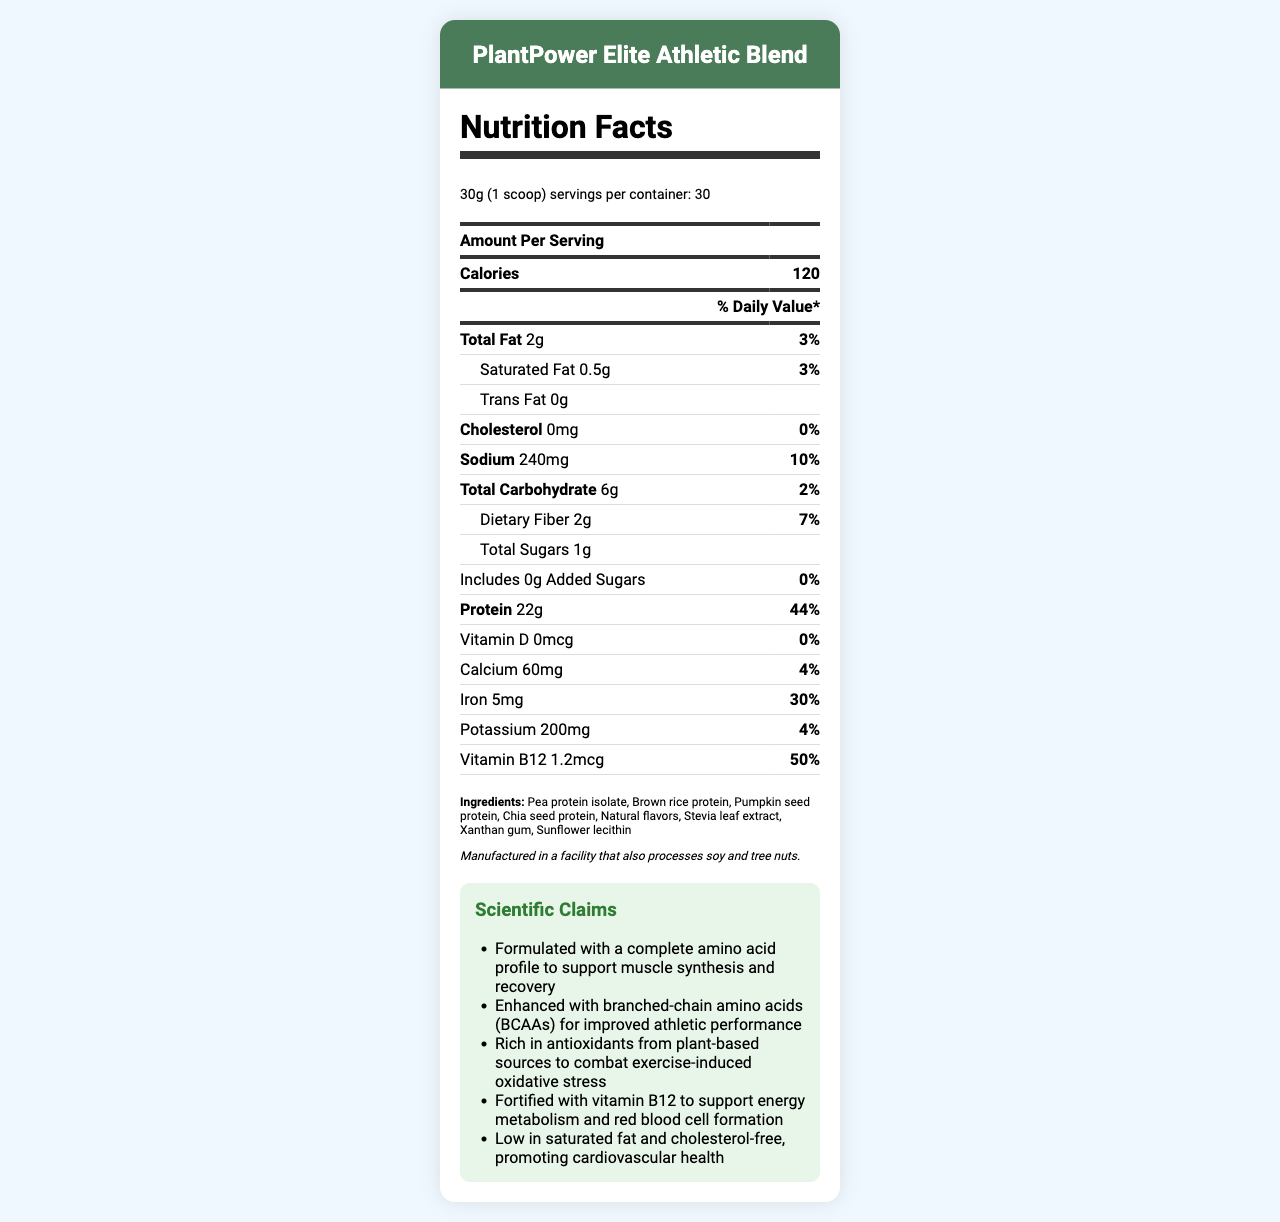what is the serving size of the PlantPower Elite Athletic Blend? The serving size information is located below the product name at the top of the document.
Answer: 30g (1 scoop) how many calories are in one serving? The number of calories per serving is listed in the Amount Per Serving section under the header "Calories."
Answer: 120 what is the total fat content per serving? The total fat content per serving is listed in the Amount Per Serving section under the "Total Fat" category.
Answer: 2g how much protein does one serving contain? The protein content per serving is listed in the Amount Per Serving section under the "Protein" category.
Answer: 22g how many servings does the container hold? The number of servings per container is located under the serving size information at the top of the document.
Answer: 30 what percentage of the Daily Value (DV) for iron does one serving provide? The percentage is listed next to the iron content in the nutrition facts table.
Answer: 30% which ingredient is not in the PlantPower Elite Athletic Blend? A. Pea protein isolate B. Whey protein C. Stevia leaf extract D. Chia seed protein The ingredients list does not include whey protein but lists Pea protein isolate, Stevia leaf extract, and Chia seed protein.
Answer: B how much dietary fiber is present in one serving? The dietary fiber content per serving is listed in the Amount Per Serving section under the "Total Carbohydrate" category.
Answer: 2g how much sodium is in one serving? A. 140mg B. 150mg C. 200mg D. 240mg The sodium content per serving is listed as 240mg in the Amount Per Serving section.
Answer: D are there any added sugars in this protein powder? The document indicates that there are 0g of added sugars in the nutrition facts table.
Answer: No is the product cholesterol-free? The document lists the cholesterol content as 0mg in the nutrition facts table.
Answer: Yes summarize the primary nutritional benefits and key claims of the PlantPower Elite Athletic Blend. The document outlines the nutritional content, key ingredients, and scientific claims including muscle synthesis support, enhanced performance, antioxidant richness, B12 fortification, and cardiovascular benefits.
Answer: The PlantPower Elite Athletic Blend provides 22g of plant-based protein, and is formulated with a complete amino acid profile, enriched with BCAAs, antioxidants, and fortified with vitamin B12. It is low in saturated fat, cholesterol-free, and supports muscle synthesis, recovery, and cardiovascular health. what is the potassium content per serving? The potassium content per serving is listed in the Amount Per Serving section under the nutrition facts table.
Answer: 200mg what is the facility allergen information? The allergen information is located at the bottom of the document where the ingredients section is also mentioned.
Answer: Manufactured in a facility that also processes soy and tree nuts. how do they enhance digestibility and bioavailability of plant proteins? The document mentions that ingredient ratios are optimized to enhance digestibility and bioavailability of plant proteins but does not detail the specific methods used.
Answer: Not enough information 